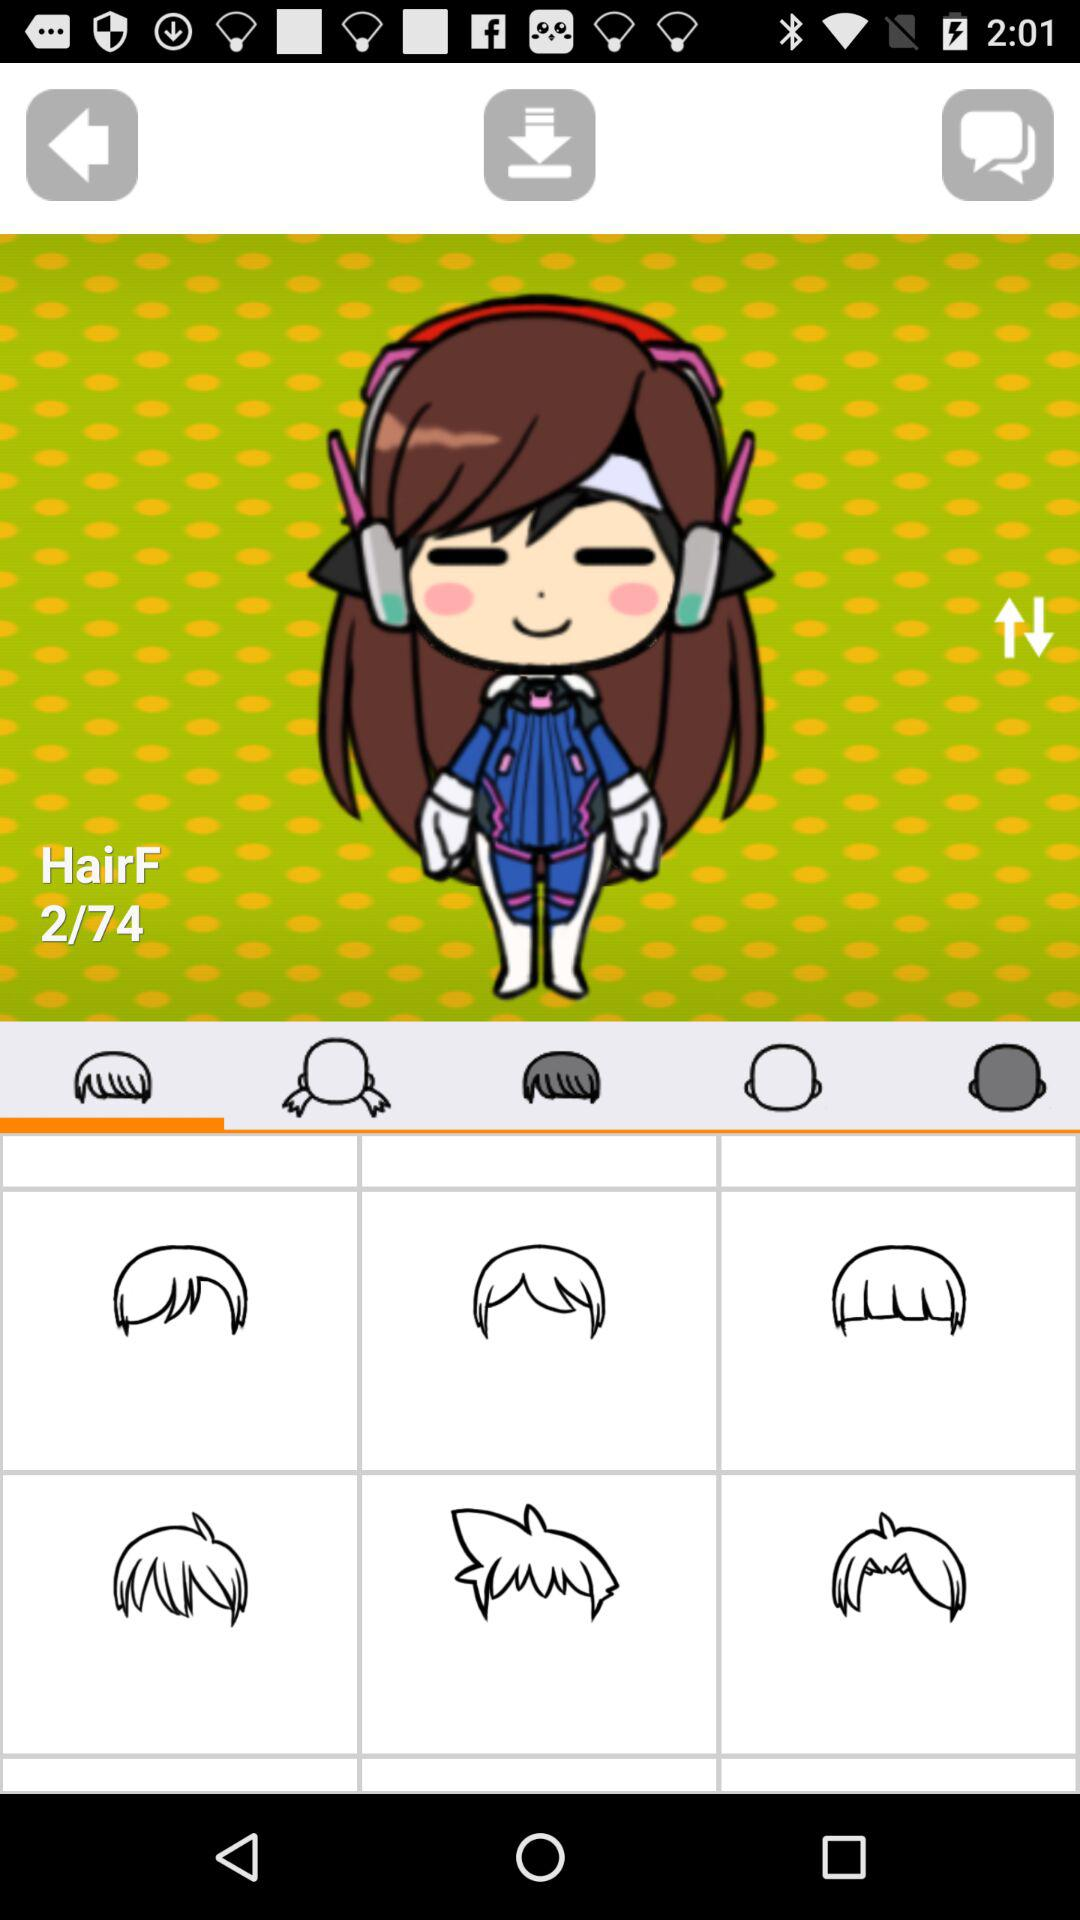Which "HairF" image am I on? You are on the 2nd "HairF" image. 